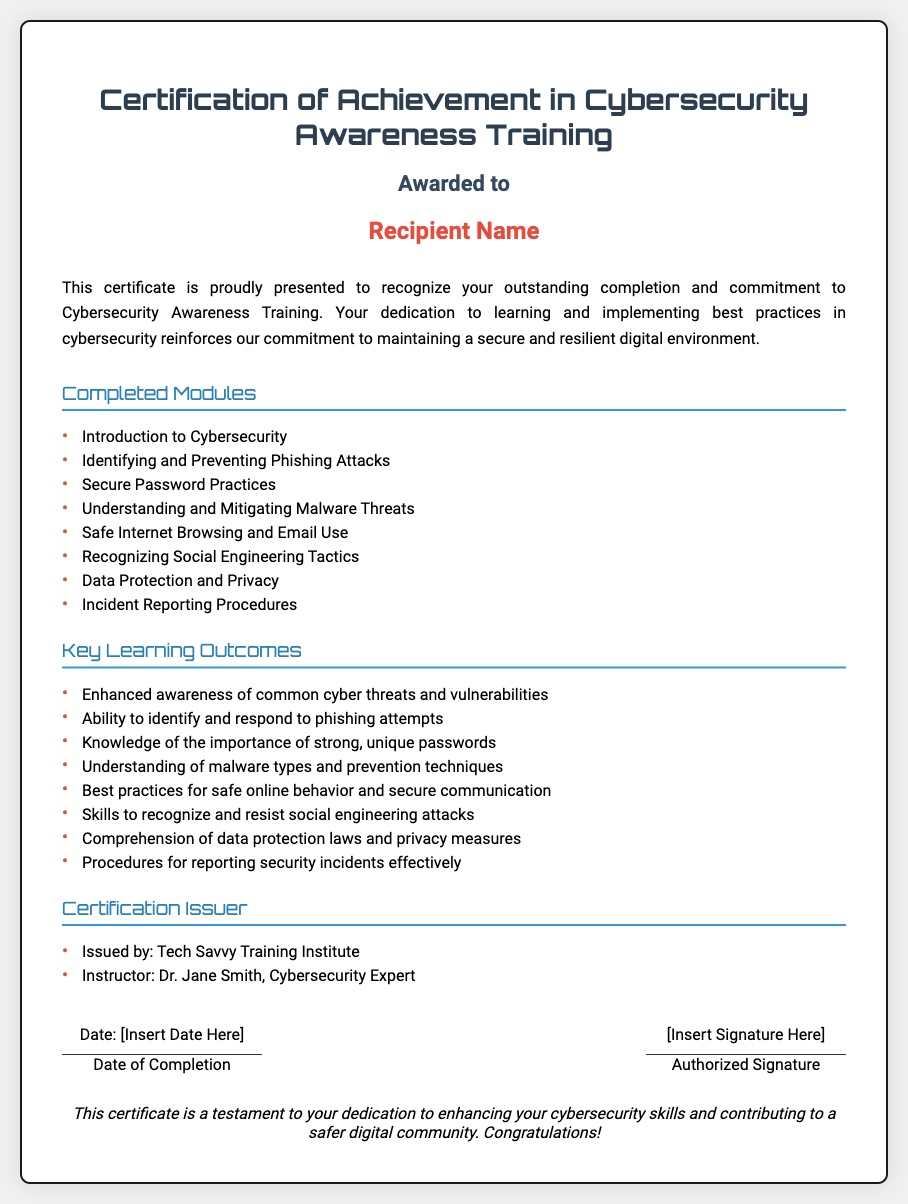What is the title of the certificate? The title of the certificate is stated prominently at the top of the document.
Answer: Certification of Achievement in Cybersecurity Awareness Training Who is the recipient of the certificate? The recipient's name is displayed in a bold format under the award section of the document.
Answer: Recipient Name What is the first module listed under Completed Modules? The document lists completed modules in a bulleted format. The first module is the first item in that list.
Answer: Introduction to Cybersecurity Who issued the certificate? The issuer of the certificate is specified in the section detailing the certification issuer, which outlines the organization responsible for the award.
Answer: Tech Savvy Training Institute What is the date section labeled as? The date section has a specific label indicating what the date represents.
Answer: Date of Completion How many key learning outcomes are listed? The document enumerates the key learning outcomes in a bulleted list, which allows for easy counting of the items.
Answer: Eight Who is the instructor mentioned on the certificate? The instructor's name can be found in the certification issuer section and is noted clearly as the person responsible for leading the training.
Answer: Dr. Jane Smith What color is used for the recipient's name? The color used for the recipient's name is specifically highlighted in the document format.
Answer: Red What is the general theme of the certificate? The document emphasizes the theme of the recipient's achievement and recognition in a specific area.
Answer: Cybersecurity Awareness Training 